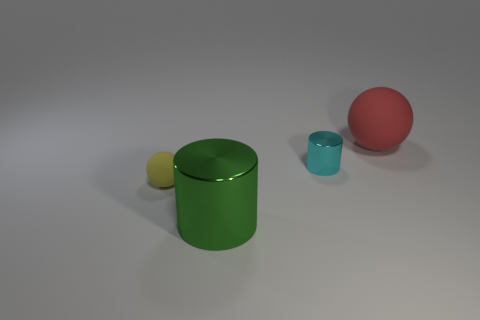Add 2 big balls. How many objects exist? 6 Add 3 big green shiny objects. How many big green shiny objects are left? 4 Add 2 big red matte spheres. How many big red matte spheres exist? 3 Subtract 1 red spheres. How many objects are left? 3 Subtract all tiny purple spheres. Subtract all tiny cyan things. How many objects are left? 3 